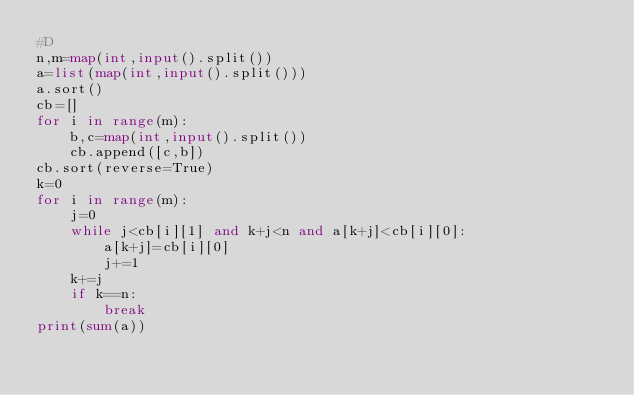<code> <loc_0><loc_0><loc_500><loc_500><_Python_>#D
n,m=map(int,input().split())
a=list(map(int,input().split()))
a.sort()
cb=[]
for i in range(m):
    b,c=map(int,input().split())
    cb.append([c,b])
cb.sort(reverse=True)
k=0
for i in range(m):
    j=0
    while j<cb[i][1] and k+j<n and a[k+j]<cb[i][0]:
        a[k+j]=cb[i][0]
        j+=1
    k+=j
    if k==n:
        break
print(sum(a))</code> 